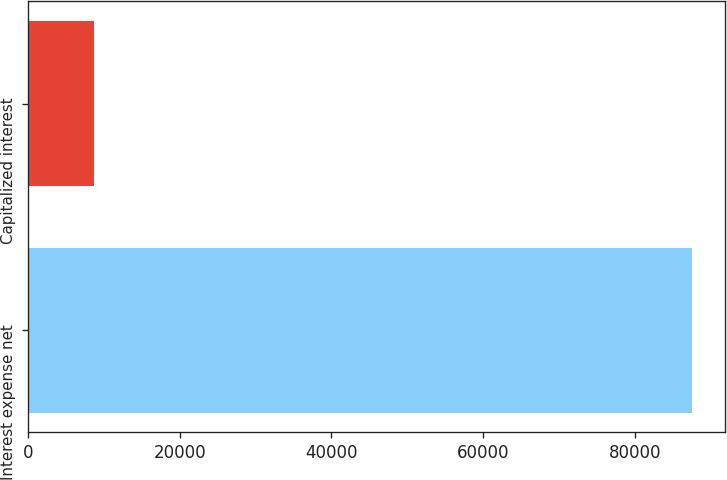<chart> <loc_0><loc_0><loc_500><loc_500><bar_chart><fcel>Interest expense net<fcel>Capitalized interest<nl><fcel>87541<fcel>8684<nl></chart> 